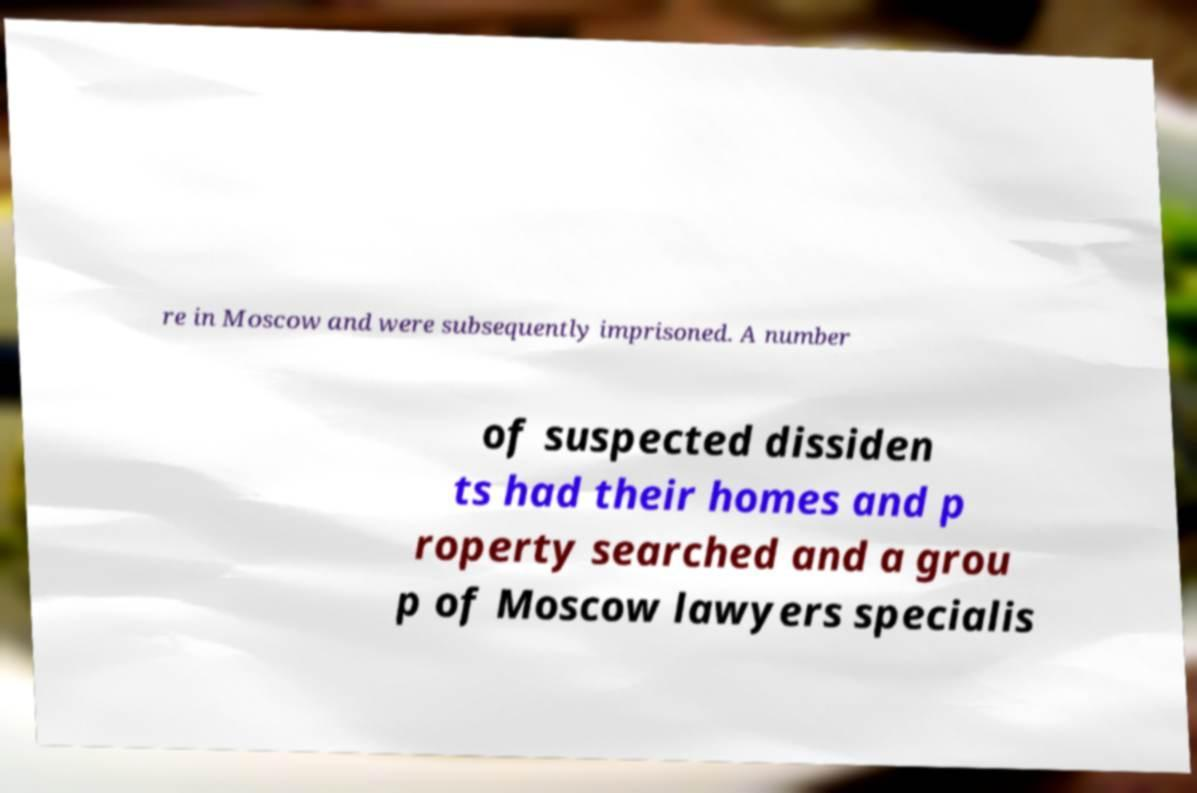Please identify and transcribe the text found in this image. re in Moscow and were subsequently imprisoned. A number of suspected dissiden ts had their homes and p roperty searched and a grou p of Moscow lawyers specialis 